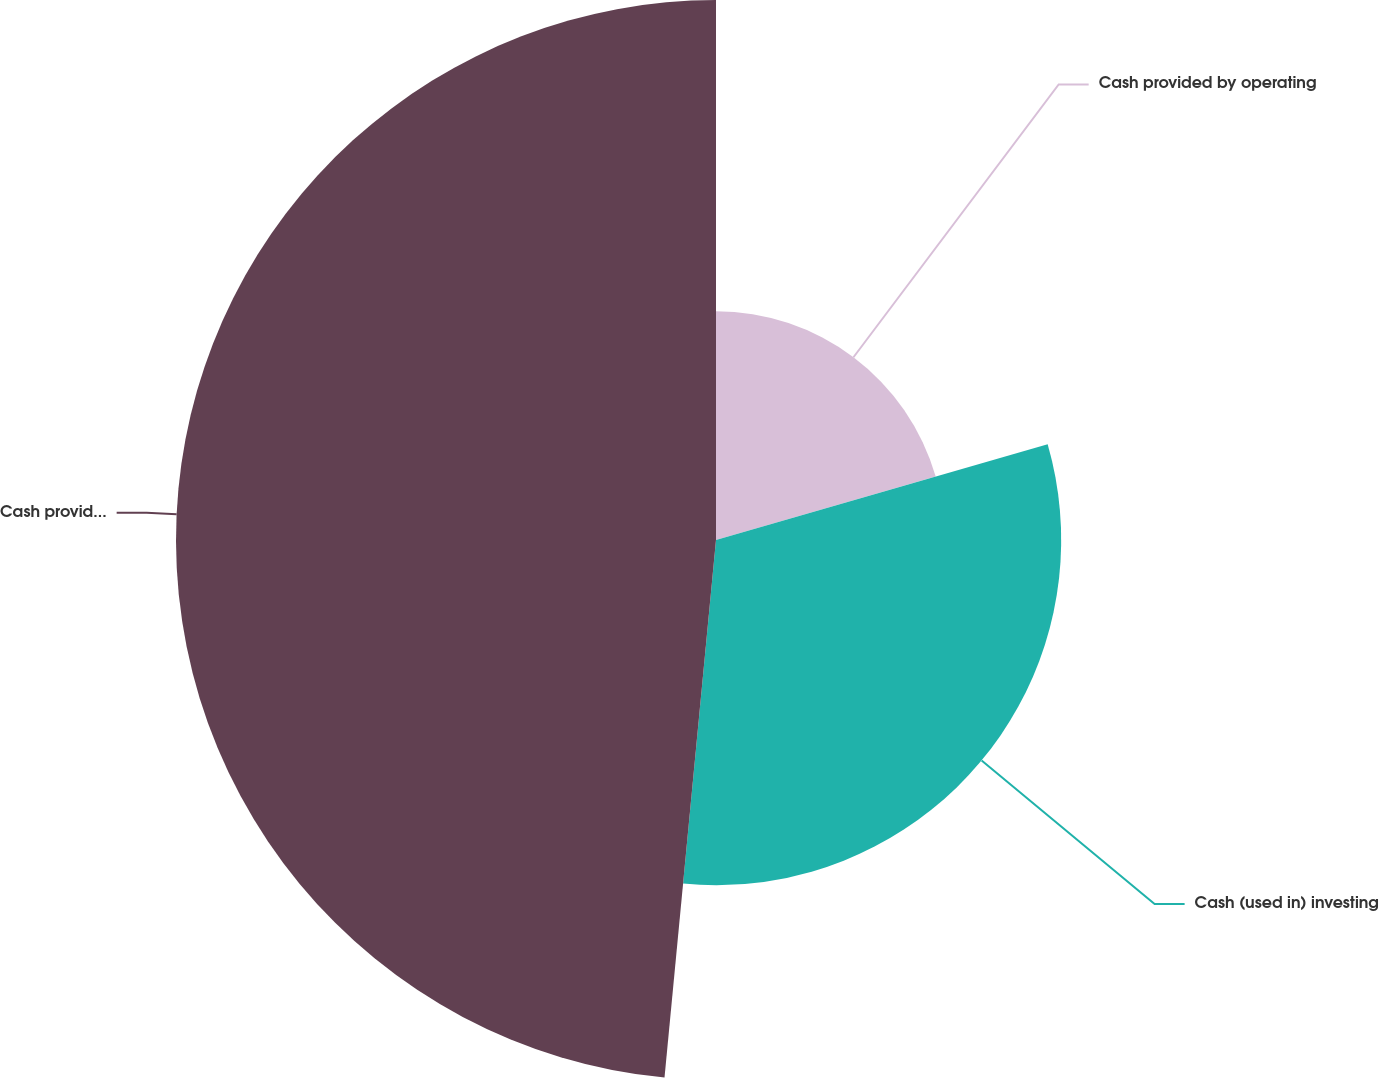Convert chart to OTSL. <chart><loc_0><loc_0><loc_500><loc_500><pie_chart><fcel>Cash provided by operating<fcel>Cash (used in) investing<fcel>Cash provided by (used in)<nl><fcel>20.53%<fcel>30.99%<fcel>48.48%<nl></chart> 